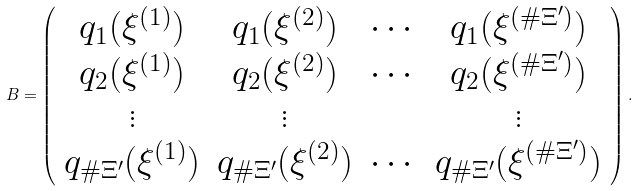<formula> <loc_0><loc_0><loc_500><loc_500>B = \left ( \begin{array} { c c c c } q _ { 1 } ( \xi ^ { ( 1 ) } ) & q _ { 1 } ( \xi ^ { ( 2 ) } ) & \cdots & q _ { 1 } ( \xi ^ { ( \# \Xi ^ { \prime } ) } ) \\ q _ { 2 } ( \xi ^ { ( 1 ) } ) & q _ { 2 } ( \xi ^ { ( 2 ) } ) & \cdots & q _ { 2 } ( \xi ^ { ( \# \Xi ^ { \prime } ) } ) \\ \vdots & \vdots & & \vdots \\ q _ { \# \Xi ^ { \prime } } ( \xi ^ { ( 1 ) } ) & q _ { \# \Xi ^ { \prime } } ( \xi ^ { ( 2 ) } ) & \cdots & q _ { \# \Xi ^ { \prime } } ( \xi ^ { ( \# \Xi ^ { \prime } ) } ) \\ \end{array} \right ) .</formula> 